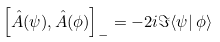<formula> <loc_0><loc_0><loc_500><loc_500>\left [ \hat { A } ( \psi ) , \hat { A } ( \phi ) \right ] _ { - } = - 2 i \Im \langle \psi | \, \phi \rangle</formula> 